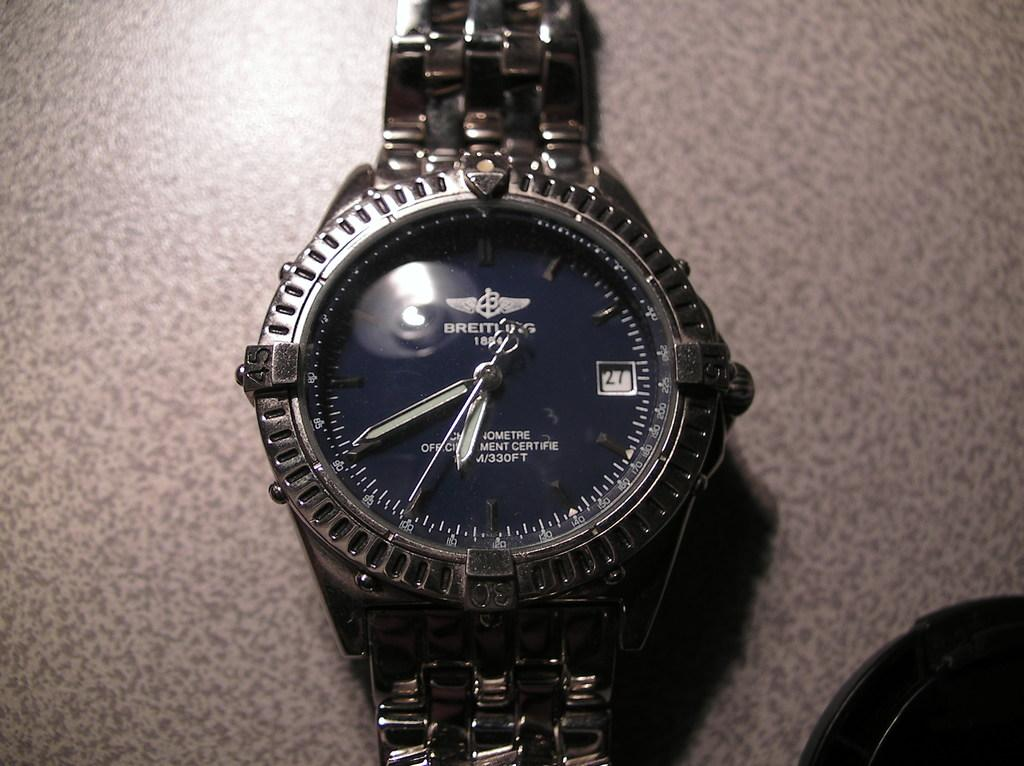Provide a one-sentence caption for the provided image. The Breathing watch design has a very sophisticated look to it. 